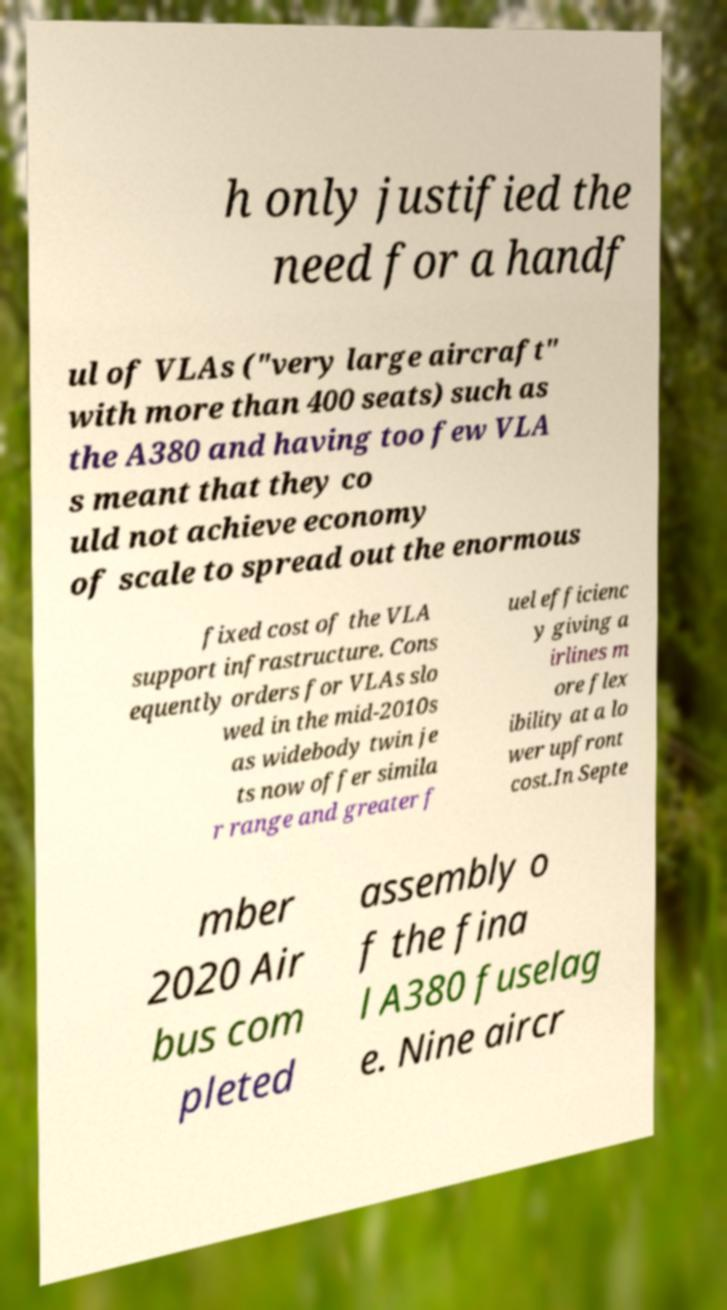Please read and relay the text visible in this image. What does it say? h only justified the need for a handf ul of VLAs ("very large aircraft" with more than 400 seats) such as the A380 and having too few VLA s meant that they co uld not achieve economy of scale to spread out the enormous fixed cost of the VLA support infrastructure. Cons equently orders for VLAs slo wed in the mid-2010s as widebody twin je ts now offer simila r range and greater f uel efficienc y giving a irlines m ore flex ibility at a lo wer upfront cost.In Septe mber 2020 Air bus com pleted assembly o f the fina l A380 fuselag e. Nine aircr 